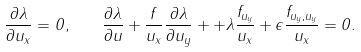Convert formula to latex. <formula><loc_0><loc_0><loc_500><loc_500>\frac { \partial \lambda } { \partial u _ { x } } = 0 , \quad \frac { \partial \lambda } { \partial u } + \frac { f } { u _ { x } } \frac { \partial \lambda } { \partial u _ { y } } + + \lambda \frac { f _ { u _ { y } } } { u _ { x } } + \epsilon \frac { f _ { u _ { y } , u _ { y } } } { u _ { x } } = 0 .</formula> 